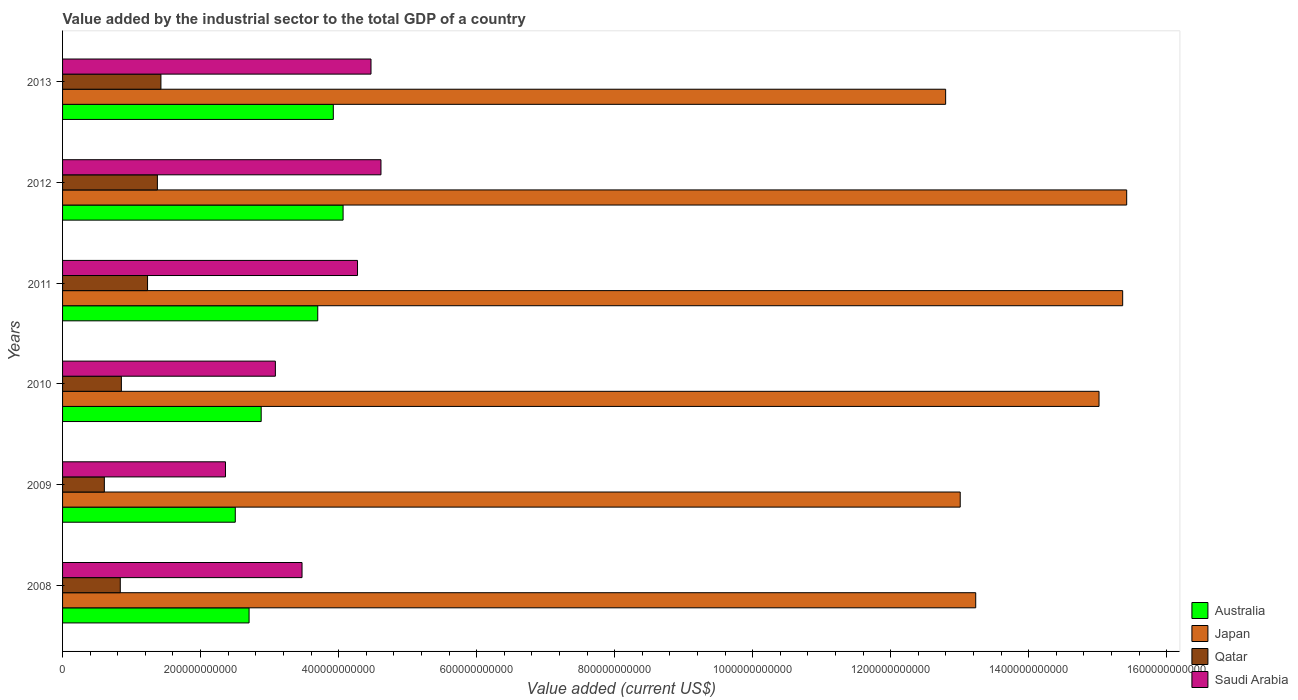How many different coloured bars are there?
Ensure brevity in your answer.  4. Are the number of bars on each tick of the Y-axis equal?
Your answer should be very brief. Yes. How many bars are there on the 1st tick from the top?
Your answer should be very brief. 4. What is the value added by the industrial sector to the total GDP in Qatar in 2013?
Keep it short and to the point. 1.43e+11. Across all years, what is the maximum value added by the industrial sector to the total GDP in Australia?
Offer a terse response. 4.07e+11. Across all years, what is the minimum value added by the industrial sector to the total GDP in Qatar?
Your answer should be very brief. 6.05e+1. In which year was the value added by the industrial sector to the total GDP in Japan maximum?
Provide a short and direct response. 2012. In which year was the value added by the industrial sector to the total GDP in Saudi Arabia minimum?
Keep it short and to the point. 2009. What is the total value added by the industrial sector to the total GDP in Japan in the graph?
Your response must be concise. 8.48e+12. What is the difference between the value added by the industrial sector to the total GDP in Qatar in 2011 and that in 2013?
Keep it short and to the point. -1.94e+1. What is the difference between the value added by the industrial sector to the total GDP in Australia in 2011 and the value added by the industrial sector to the total GDP in Japan in 2012?
Your answer should be very brief. -1.17e+12. What is the average value added by the industrial sector to the total GDP in Australia per year?
Make the answer very short. 3.30e+11. In the year 2013, what is the difference between the value added by the industrial sector to the total GDP in Saudi Arabia and value added by the industrial sector to the total GDP in Japan?
Keep it short and to the point. -8.33e+11. What is the ratio of the value added by the industrial sector to the total GDP in Japan in 2008 to that in 2010?
Your answer should be very brief. 0.88. What is the difference between the highest and the second highest value added by the industrial sector to the total GDP in Qatar?
Offer a very short reply. 5.11e+09. What is the difference between the highest and the lowest value added by the industrial sector to the total GDP in Qatar?
Your answer should be compact. 8.20e+1. Is it the case that in every year, the sum of the value added by the industrial sector to the total GDP in Qatar and value added by the industrial sector to the total GDP in Saudi Arabia is greater than the sum of value added by the industrial sector to the total GDP in Japan and value added by the industrial sector to the total GDP in Australia?
Your answer should be very brief. No. How many years are there in the graph?
Your answer should be compact. 6. What is the difference between two consecutive major ticks on the X-axis?
Provide a short and direct response. 2.00e+11. Does the graph contain grids?
Offer a very short reply. No. How are the legend labels stacked?
Keep it short and to the point. Vertical. What is the title of the graph?
Your answer should be very brief. Value added by the industrial sector to the total GDP of a country. What is the label or title of the X-axis?
Make the answer very short. Value added (current US$). What is the Value added (current US$) in Australia in 2008?
Make the answer very short. 2.70e+11. What is the Value added (current US$) in Japan in 2008?
Provide a succinct answer. 1.32e+12. What is the Value added (current US$) of Qatar in 2008?
Give a very brief answer. 8.36e+1. What is the Value added (current US$) of Saudi Arabia in 2008?
Keep it short and to the point. 3.47e+11. What is the Value added (current US$) in Australia in 2009?
Provide a succinct answer. 2.50e+11. What is the Value added (current US$) in Japan in 2009?
Your answer should be compact. 1.30e+12. What is the Value added (current US$) in Qatar in 2009?
Ensure brevity in your answer.  6.05e+1. What is the Value added (current US$) in Saudi Arabia in 2009?
Your answer should be very brief. 2.36e+11. What is the Value added (current US$) of Australia in 2010?
Your answer should be compact. 2.88e+11. What is the Value added (current US$) in Japan in 2010?
Your response must be concise. 1.50e+12. What is the Value added (current US$) in Qatar in 2010?
Your response must be concise. 8.52e+1. What is the Value added (current US$) of Saudi Arabia in 2010?
Make the answer very short. 3.08e+11. What is the Value added (current US$) of Australia in 2011?
Your answer should be compact. 3.70e+11. What is the Value added (current US$) in Japan in 2011?
Give a very brief answer. 1.54e+12. What is the Value added (current US$) of Qatar in 2011?
Your answer should be very brief. 1.23e+11. What is the Value added (current US$) in Saudi Arabia in 2011?
Ensure brevity in your answer.  4.27e+11. What is the Value added (current US$) in Australia in 2012?
Provide a short and direct response. 4.07e+11. What is the Value added (current US$) of Japan in 2012?
Your answer should be compact. 1.54e+12. What is the Value added (current US$) in Qatar in 2012?
Offer a very short reply. 1.37e+11. What is the Value added (current US$) of Saudi Arabia in 2012?
Offer a terse response. 4.61e+11. What is the Value added (current US$) in Australia in 2013?
Keep it short and to the point. 3.92e+11. What is the Value added (current US$) of Japan in 2013?
Give a very brief answer. 1.28e+12. What is the Value added (current US$) in Qatar in 2013?
Keep it short and to the point. 1.43e+11. What is the Value added (current US$) of Saudi Arabia in 2013?
Make the answer very short. 4.47e+11. Across all years, what is the maximum Value added (current US$) in Australia?
Your answer should be compact. 4.07e+11. Across all years, what is the maximum Value added (current US$) in Japan?
Provide a succinct answer. 1.54e+12. Across all years, what is the maximum Value added (current US$) in Qatar?
Your answer should be very brief. 1.43e+11. Across all years, what is the maximum Value added (current US$) in Saudi Arabia?
Offer a very short reply. 4.61e+11. Across all years, what is the minimum Value added (current US$) in Australia?
Provide a short and direct response. 2.50e+11. Across all years, what is the minimum Value added (current US$) of Japan?
Make the answer very short. 1.28e+12. Across all years, what is the minimum Value added (current US$) of Qatar?
Keep it short and to the point. 6.05e+1. Across all years, what is the minimum Value added (current US$) of Saudi Arabia?
Your answer should be compact. 2.36e+11. What is the total Value added (current US$) in Australia in the graph?
Give a very brief answer. 1.98e+12. What is the total Value added (current US$) in Japan in the graph?
Offer a very short reply. 8.48e+12. What is the total Value added (current US$) in Qatar in the graph?
Ensure brevity in your answer.  6.32e+11. What is the total Value added (current US$) of Saudi Arabia in the graph?
Offer a very short reply. 2.23e+12. What is the difference between the Value added (current US$) of Australia in 2008 and that in 2009?
Keep it short and to the point. 2.00e+1. What is the difference between the Value added (current US$) of Japan in 2008 and that in 2009?
Ensure brevity in your answer.  2.25e+1. What is the difference between the Value added (current US$) of Qatar in 2008 and that in 2009?
Make the answer very short. 2.31e+1. What is the difference between the Value added (current US$) of Saudi Arabia in 2008 and that in 2009?
Ensure brevity in your answer.  1.11e+11. What is the difference between the Value added (current US$) of Australia in 2008 and that in 2010?
Offer a very short reply. -1.75e+1. What is the difference between the Value added (current US$) of Japan in 2008 and that in 2010?
Your answer should be compact. -1.79e+11. What is the difference between the Value added (current US$) of Qatar in 2008 and that in 2010?
Ensure brevity in your answer.  -1.58e+09. What is the difference between the Value added (current US$) of Saudi Arabia in 2008 and that in 2010?
Offer a very short reply. 3.86e+1. What is the difference between the Value added (current US$) in Australia in 2008 and that in 2011?
Your response must be concise. -9.95e+1. What is the difference between the Value added (current US$) of Japan in 2008 and that in 2011?
Your answer should be compact. -2.13e+11. What is the difference between the Value added (current US$) in Qatar in 2008 and that in 2011?
Provide a short and direct response. -3.95e+1. What is the difference between the Value added (current US$) of Saudi Arabia in 2008 and that in 2011?
Offer a terse response. -8.04e+1. What is the difference between the Value added (current US$) in Australia in 2008 and that in 2012?
Give a very brief answer. -1.36e+11. What is the difference between the Value added (current US$) in Japan in 2008 and that in 2012?
Your response must be concise. -2.19e+11. What is the difference between the Value added (current US$) in Qatar in 2008 and that in 2012?
Offer a terse response. -5.38e+1. What is the difference between the Value added (current US$) of Saudi Arabia in 2008 and that in 2012?
Provide a succinct answer. -1.14e+11. What is the difference between the Value added (current US$) in Australia in 2008 and that in 2013?
Keep it short and to the point. -1.22e+11. What is the difference between the Value added (current US$) of Japan in 2008 and that in 2013?
Provide a short and direct response. 4.36e+1. What is the difference between the Value added (current US$) of Qatar in 2008 and that in 2013?
Give a very brief answer. -5.89e+1. What is the difference between the Value added (current US$) in Saudi Arabia in 2008 and that in 2013?
Ensure brevity in your answer.  -1.00e+11. What is the difference between the Value added (current US$) in Australia in 2009 and that in 2010?
Keep it short and to the point. -3.75e+1. What is the difference between the Value added (current US$) of Japan in 2009 and that in 2010?
Your answer should be very brief. -2.01e+11. What is the difference between the Value added (current US$) in Qatar in 2009 and that in 2010?
Keep it short and to the point. -2.47e+1. What is the difference between the Value added (current US$) of Saudi Arabia in 2009 and that in 2010?
Give a very brief answer. -7.23e+1. What is the difference between the Value added (current US$) in Australia in 2009 and that in 2011?
Provide a succinct answer. -1.20e+11. What is the difference between the Value added (current US$) in Japan in 2009 and that in 2011?
Ensure brevity in your answer.  -2.35e+11. What is the difference between the Value added (current US$) in Qatar in 2009 and that in 2011?
Your answer should be compact. -6.26e+1. What is the difference between the Value added (current US$) of Saudi Arabia in 2009 and that in 2011?
Offer a terse response. -1.91e+11. What is the difference between the Value added (current US$) of Australia in 2009 and that in 2012?
Your answer should be compact. -1.56e+11. What is the difference between the Value added (current US$) in Japan in 2009 and that in 2012?
Ensure brevity in your answer.  -2.41e+11. What is the difference between the Value added (current US$) in Qatar in 2009 and that in 2012?
Ensure brevity in your answer.  -7.69e+1. What is the difference between the Value added (current US$) in Saudi Arabia in 2009 and that in 2012?
Make the answer very short. -2.25e+11. What is the difference between the Value added (current US$) in Australia in 2009 and that in 2013?
Your answer should be very brief. -1.42e+11. What is the difference between the Value added (current US$) in Japan in 2009 and that in 2013?
Your response must be concise. 2.11e+1. What is the difference between the Value added (current US$) in Qatar in 2009 and that in 2013?
Give a very brief answer. -8.20e+1. What is the difference between the Value added (current US$) of Saudi Arabia in 2009 and that in 2013?
Your answer should be very brief. -2.11e+11. What is the difference between the Value added (current US$) of Australia in 2010 and that in 2011?
Keep it short and to the point. -8.20e+1. What is the difference between the Value added (current US$) in Japan in 2010 and that in 2011?
Keep it short and to the point. -3.43e+1. What is the difference between the Value added (current US$) in Qatar in 2010 and that in 2011?
Your answer should be very brief. -3.79e+1. What is the difference between the Value added (current US$) of Saudi Arabia in 2010 and that in 2011?
Provide a succinct answer. -1.19e+11. What is the difference between the Value added (current US$) in Australia in 2010 and that in 2012?
Your answer should be very brief. -1.19e+11. What is the difference between the Value added (current US$) in Japan in 2010 and that in 2012?
Your answer should be very brief. -4.01e+1. What is the difference between the Value added (current US$) in Qatar in 2010 and that in 2012?
Give a very brief answer. -5.22e+1. What is the difference between the Value added (current US$) in Saudi Arabia in 2010 and that in 2012?
Offer a terse response. -1.53e+11. What is the difference between the Value added (current US$) of Australia in 2010 and that in 2013?
Your answer should be compact. -1.05e+11. What is the difference between the Value added (current US$) of Japan in 2010 and that in 2013?
Offer a very short reply. 2.22e+11. What is the difference between the Value added (current US$) in Qatar in 2010 and that in 2013?
Give a very brief answer. -5.73e+1. What is the difference between the Value added (current US$) in Saudi Arabia in 2010 and that in 2013?
Keep it short and to the point. -1.39e+11. What is the difference between the Value added (current US$) of Australia in 2011 and that in 2012?
Keep it short and to the point. -3.67e+1. What is the difference between the Value added (current US$) of Japan in 2011 and that in 2012?
Give a very brief answer. -5.83e+09. What is the difference between the Value added (current US$) of Qatar in 2011 and that in 2012?
Provide a succinct answer. -1.43e+1. What is the difference between the Value added (current US$) in Saudi Arabia in 2011 and that in 2012?
Ensure brevity in your answer.  -3.40e+1. What is the difference between the Value added (current US$) of Australia in 2011 and that in 2013?
Offer a very short reply. -2.25e+1. What is the difference between the Value added (current US$) of Japan in 2011 and that in 2013?
Your answer should be compact. 2.57e+11. What is the difference between the Value added (current US$) of Qatar in 2011 and that in 2013?
Provide a short and direct response. -1.94e+1. What is the difference between the Value added (current US$) in Saudi Arabia in 2011 and that in 2013?
Ensure brevity in your answer.  -1.95e+1. What is the difference between the Value added (current US$) of Australia in 2012 and that in 2013?
Offer a terse response. 1.42e+1. What is the difference between the Value added (current US$) of Japan in 2012 and that in 2013?
Provide a succinct answer. 2.62e+11. What is the difference between the Value added (current US$) in Qatar in 2012 and that in 2013?
Offer a very short reply. -5.11e+09. What is the difference between the Value added (current US$) in Saudi Arabia in 2012 and that in 2013?
Offer a very short reply. 1.44e+1. What is the difference between the Value added (current US$) in Australia in 2008 and the Value added (current US$) in Japan in 2009?
Ensure brevity in your answer.  -1.03e+12. What is the difference between the Value added (current US$) in Australia in 2008 and the Value added (current US$) in Qatar in 2009?
Offer a very short reply. 2.10e+11. What is the difference between the Value added (current US$) in Australia in 2008 and the Value added (current US$) in Saudi Arabia in 2009?
Provide a short and direct response. 3.42e+1. What is the difference between the Value added (current US$) of Japan in 2008 and the Value added (current US$) of Qatar in 2009?
Your response must be concise. 1.26e+12. What is the difference between the Value added (current US$) in Japan in 2008 and the Value added (current US$) in Saudi Arabia in 2009?
Your response must be concise. 1.09e+12. What is the difference between the Value added (current US$) in Qatar in 2008 and the Value added (current US$) in Saudi Arabia in 2009?
Offer a very short reply. -1.52e+11. What is the difference between the Value added (current US$) of Australia in 2008 and the Value added (current US$) of Japan in 2010?
Your answer should be very brief. -1.23e+12. What is the difference between the Value added (current US$) in Australia in 2008 and the Value added (current US$) in Qatar in 2010?
Offer a terse response. 1.85e+11. What is the difference between the Value added (current US$) of Australia in 2008 and the Value added (current US$) of Saudi Arabia in 2010?
Make the answer very short. -3.81e+1. What is the difference between the Value added (current US$) of Japan in 2008 and the Value added (current US$) of Qatar in 2010?
Provide a succinct answer. 1.24e+12. What is the difference between the Value added (current US$) of Japan in 2008 and the Value added (current US$) of Saudi Arabia in 2010?
Make the answer very short. 1.01e+12. What is the difference between the Value added (current US$) of Qatar in 2008 and the Value added (current US$) of Saudi Arabia in 2010?
Provide a succinct answer. -2.25e+11. What is the difference between the Value added (current US$) of Australia in 2008 and the Value added (current US$) of Japan in 2011?
Ensure brevity in your answer.  -1.27e+12. What is the difference between the Value added (current US$) of Australia in 2008 and the Value added (current US$) of Qatar in 2011?
Give a very brief answer. 1.47e+11. What is the difference between the Value added (current US$) of Australia in 2008 and the Value added (current US$) of Saudi Arabia in 2011?
Your answer should be compact. -1.57e+11. What is the difference between the Value added (current US$) of Japan in 2008 and the Value added (current US$) of Qatar in 2011?
Make the answer very short. 1.20e+12. What is the difference between the Value added (current US$) in Japan in 2008 and the Value added (current US$) in Saudi Arabia in 2011?
Provide a short and direct response. 8.96e+11. What is the difference between the Value added (current US$) in Qatar in 2008 and the Value added (current US$) in Saudi Arabia in 2011?
Offer a very short reply. -3.44e+11. What is the difference between the Value added (current US$) in Australia in 2008 and the Value added (current US$) in Japan in 2012?
Ensure brevity in your answer.  -1.27e+12. What is the difference between the Value added (current US$) of Australia in 2008 and the Value added (current US$) of Qatar in 2012?
Your answer should be very brief. 1.33e+11. What is the difference between the Value added (current US$) in Australia in 2008 and the Value added (current US$) in Saudi Arabia in 2012?
Make the answer very short. -1.91e+11. What is the difference between the Value added (current US$) in Japan in 2008 and the Value added (current US$) in Qatar in 2012?
Give a very brief answer. 1.19e+12. What is the difference between the Value added (current US$) of Japan in 2008 and the Value added (current US$) of Saudi Arabia in 2012?
Provide a short and direct response. 8.62e+11. What is the difference between the Value added (current US$) in Qatar in 2008 and the Value added (current US$) in Saudi Arabia in 2012?
Keep it short and to the point. -3.78e+11. What is the difference between the Value added (current US$) in Australia in 2008 and the Value added (current US$) in Japan in 2013?
Your answer should be very brief. -1.01e+12. What is the difference between the Value added (current US$) of Australia in 2008 and the Value added (current US$) of Qatar in 2013?
Provide a succinct answer. 1.28e+11. What is the difference between the Value added (current US$) of Australia in 2008 and the Value added (current US$) of Saudi Arabia in 2013?
Provide a short and direct response. -1.77e+11. What is the difference between the Value added (current US$) in Japan in 2008 and the Value added (current US$) in Qatar in 2013?
Offer a terse response. 1.18e+12. What is the difference between the Value added (current US$) of Japan in 2008 and the Value added (current US$) of Saudi Arabia in 2013?
Keep it short and to the point. 8.76e+11. What is the difference between the Value added (current US$) of Qatar in 2008 and the Value added (current US$) of Saudi Arabia in 2013?
Offer a terse response. -3.63e+11. What is the difference between the Value added (current US$) of Australia in 2009 and the Value added (current US$) of Japan in 2010?
Your response must be concise. -1.25e+12. What is the difference between the Value added (current US$) of Australia in 2009 and the Value added (current US$) of Qatar in 2010?
Your answer should be compact. 1.65e+11. What is the difference between the Value added (current US$) in Australia in 2009 and the Value added (current US$) in Saudi Arabia in 2010?
Ensure brevity in your answer.  -5.81e+1. What is the difference between the Value added (current US$) of Japan in 2009 and the Value added (current US$) of Qatar in 2010?
Your answer should be very brief. 1.22e+12. What is the difference between the Value added (current US$) of Japan in 2009 and the Value added (current US$) of Saudi Arabia in 2010?
Keep it short and to the point. 9.92e+11. What is the difference between the Value added (current US$) in Qatar in 2009 and the Value added (current US$) in Saudi Arabia in 2010?
Ensure brevity in your answer.  -2.48e+11. What is the difference between the Value added (current US$) in Australia in 2009 and the Value added (current US$) in Japan in 2011?
Give a very brief answer. -1.29e+12. What is the difference between the Value added (current US$) in Australia in 2009 and the Value added (current US$) in Qatar in 2011?
Make the answer very short. 1.27e+11. What is the difference between the Value added (current US$) of Australia in 2009 and the Value added (current US$) of Saudi Arabia in 2011?
Give a very brief answer. -1.77e+11. What is the difference between the Value added (current US$) of Japan in 2009 and the Value added (current US$) of Qatar in 2011?
Your answer should be very brief. 1.18e+12. What is the difference between the Value added (current US$) in Japan in 2009 and the Value added (current US$) in Saudi Arabia in 2011?
Your answer should be compact. 8.73e+11. What is the difference between the Value added (current US$) in Qatar in 2009 and the Value added (current US$) in Saudi Arabia in 2011?
Your answer should be compact. -3.67e+11. What is the difference between the Value added (current US$) of Australia in 2009 and the Value added (current US$) of Japan in 2012?
Provide a succinct answer. -1.29e+12. What is the difference between the Value added (current US$) in Australia in 2009 and the Value added (current US$) in Qatar in 2012?
Your answer should be compact. 1.13e+11. What is the difference between the Value added (current US$) of Australia in 2009 and the Value added (current US$) of Saudi Arabia in 2012?
Your response must be concise. -2.11e+11. What is the difference between the Value added (current US$) in Japan in 2009 and the Value added (current US$) in Qatar in 2012?
Give a very brief answer. 1.16e+12. What is the difference between the Value added (current US$) in Japan in 2009 and the Value added (current US$) in Saudi Arabia in 2012?
Offer a very short reply. 8.39e+11. What is the difference between the Value added (current US$) in Qatar in 2009 and the Value added (current US$) in Saudi Arabia in 2012?
Ensure brevity in your answer.  -4.01e+11. What is the difference between the Value added (current US$) in Australia in 2009 and the Value added (current US$) in Japan in 2013?
Your answer should be compact. -1.03e+12. What is the difference between the Value added (current US$) of Australia in 2009 and the Value added (current US$) of Qatar in 2013?
Provide a short and direct response. 1.08e+11. What is the difference between the Value added (current US$) in Australia in 2009 and the Value added (current US$) in Saudi Arabia in 2013?
Your response must be concise. -1.97e+11. What is the difference between the Value added (current US$) of Japan in 2009 and the Value added (current US$) of Qatar in 2013?
Your answer should be compact. 1.16e+12. What is the difference between the Value added (current US$) of Japan in 2009 and the Value added (current US$) of Saudi Arabia in 2013?
Give a very brief answer. 8.54e+11. What is the difference between the Value added (current US$) in Qatar in 2009 and the Value added (current US$) in Saudi Arabia in 2013?
Your response must be concise. -3.86e+11. What is the difference between the Value added (current US$) of Australia in 2010 and the Value added (current US$) of Japan in 2011?
Keep it short and to the point. -1.25e+12. What is the difference between the Value added (current US$) in Australia in 2010 and the Value added (current US$) in Qatar in 2011?
Keep it short and to the point. 1.65e+11. What is the difference between the Value added (current US$) of Australia in 2010 and the Value added (current US$) of Saudi Arabia in 2011?
Offer a very short reply. -1.40e+11. What is the difference between the Value added (current US$) of Japan in 2010 and the Value added (current US$) of Qatar in 2011?
Offer a terse response. 1.38e+12. What is the difference between the Value added (current US$) in Japan in 2010 and the Value added (current US$) in Saudi Arabia in 2011?
Your answer should be compact. 1.07e+12. What is the difference between the Value added (current US$) of Qatar in 2010 and the Value added (current US$) of Saudi Arabia in 2011?
Your response must be concise. -3.42e+11. What is the difference between the Value added (current US$) in Australia in 2010 and the Value added (current US$) in Japan in 2012?
Ensure brevity in your answer.  -1.25e+12. What is the difference between the Value added (current US$) of Australia in 2010 and the Value added (current US$) of Qatar in 2012?
Offer a very short reply. 1.50e+11. What is the difference between the Value added (current US$) of Australia in 2010 and the Value added (current US$) of Saudi Arabia in 2012?
Offer a terse response. -1.74e+11. What is the difference between the Value added (current US$) of Japan in 2010 and the Value added (current US$) of Qatar in 2012?
Make the answer very short. 1.36e+12. What is the difference between the Value added (current US$) of Japan in 2010 and the Value added (current US$) of Saudi Arabia in 2012?
Your answer should be very brief. 1.04e+12. What is the difference between the Value added (current US$) in Qatar in 2010 and the Value added (current US$) in Saudi Arabia in 2012?
Keep it short and to the point. -3.76e+11. What is the difference between the Value added (current US$) in Australia in 2010 and the Value added (current US$) in Japan in 2013?
Ensure brevity in your answer.  -9.92e+11. What is the difference between the Value added (current US$) of Australia in 2010 and the Value added (current US$) of Qatar in 2013?
Give a very brief answer. 1.45e+11. What is the difference between the Value added (current US$) in Australia in 2010 and the Value added (current US$) in Saudi Arabia in 2013?
Provide a succinct answer. -1.59e+11. What is the difference between the Value added (current US$) in Japan in 2010 and the Value added (current US$) in Qatar in 2013?
Give a very brief answer. 1.36e+12. What is the difference between the Value added (current US$) of Japan in 2010 and the Value added (current US$) of Saudi Arabia in 2013?
Your answer should be very brief. 1.05e+12. What is the difference between the Value added (current US$) in Qatar in 2010 and the Value added (current US$) in Saudi Arabia in 2013?
Offer a very short reply. -3.62e+11. What is the difference between the Value added (current US$) of Australia in 2011 and the Value added (current US$) of Japan in 2012?
Give a very brief answer. -1.17e+12. What is the difference between the Value added (current US$) in Australia in 2011 and the Value added (current US$) in Qatar in 2012?
Your response must be concise. 2.32e+11. What is the difference between the Value added (current US$) in Australia in 2011 and the Value added (current US$) in Saudi Arabia in 2012?
Your answer should be compact. -9.16e+1. What is the difference between the Value added (current US$) in Japan in 2011 and the Value added (current US$) in Qatar in 2012?
Your answer should be very brief. 1.40e+12. What is the difference between the Value added (current US$) of Japan in 2011 and the Value added (current US$) of Saudi Arabia in 2012?
Your answer should be compact. 1.07e+12. What is the difference between the Value added (current US$) of Qatar in 2011 and the Value added (current US$) of Saudi Arabia in 2012?
Your answer should be very brief. -3.38e+11. What is the difference between the Value added (current US$) of Australia in 2011 and the Value added (current US$) of Japan in 2013?
Provide a succinct answer. -9.10e+11. What is the difference between the Value added (current US$) of Australia in 2011 and the Value added (current US$) of Qatar in 2013?
Offer a very short reply. 2.27e+11. What is the difference between the Value added (current US$) of Australia in 2011 and the Value added (current US$) of Saudi Arabia in 2013?
Provide a short and direct response. -7.72e+1. What is the difference between the Value added (current US$) in Japan in 2011 and the Value added (current US$) in Qatar in 2013?
Your answer should be very brief. 1.39e+12. What is the difference between the Value added (current US$) of Japan in 2011 and the Value added (current US$) of Saudi Arabia in 2013?
Your response must be concise. 1.09e+12. What is the difference between the Value added (current US$) in Qatar in 2011 and the Value added (current US$) in Saudi Arabia in 2013?
Keep it short and to the point. -3.24e+11. What is the difference between the Value added (current US$) of Australia in 2012 and the Value added (current US$) of Japan in 2013?
Ensure brevity in your answer.  -8.73e+11. What is the difference between the Value added (current US$) in Australia in 2012 and the Value added (current US$) in Qatar in 2013?
Your response must be concise. 2.64e+11. What is the difference between the Value added (current US$) of Australia in 2012 and the Value added (current US$) of Saudi Arabia in 2013?
Provide a short and direct response. -4.04e+1. What is the difference between the Value added (current US$) of Japan in 2012 and the Value added (current US$) of Qatar in 2013?
Your answer should be very brief. 1.40e+12. What is the difference between the Value added (current US$) in Japan in 2012 and the Value added (current US$) in Saudi Arabia in 2013?
Provide a succinct answer. 1.10e+12. What is the difference between the Value added (current US$) in Qatar in 2012 and the Value added (current US$) in Saudi Arabia in 2013?
Keep it short and to the point. -3.10e+11. What is the average Value added (current US$) in Australia per year?
Your answer should be compact. 3.30e+11. What is the average Value added (current US$) in Japan per year?
Your response must be concise. 1.41e+12. What is the average Value added (current US$) in Qatar per year?
Your response must be concise. 1.05e+11. What is the average Value added (current US$) of Saudi Arabia per year?
Offer a terse response. 3.71e+11. In the year 2008, what is the difference between the Value added (current US$) of Australia and Value added (current US$) of Japan?
Your answer should be very brief. -1.05e+12. In the year 2008, what is the difference between the Value added (current US$) of Australia and Value added (current US$) of Qatar?
Your response must be concise. 1.87e+11. In the year 2008, what is the difference between the Value added (current US$) in Australia and Value added (current US$) in Saudi Arabia?
Your answer should be very brief. -7.67e+1. In the year 2008, what is the difference between the Value added (current US$) of Japan and Value added (current US$) of Qatar?
Ensure brevity in your answer.  1.24e+12. In the year 2008, what is the difference between the Value added (current US$) of Japan and Value added (current US$) of Saudi Arabia?
Give a very brief answer. 9.76e+11. In the year 2008, what is the difference between the Value added (current US$) of Qatar and Value added (current US$) of Saudi Arabia?
Give a very brief answer. -2.63e+11. In the year 2009, what is the difference between the Value added (current US$) of Australia and Value added (current US$) of Japan?
Offer a terse response. -1.05e+12. In the year 2009, what is the difference between the Value added (current US$) in Australia and Value added (current US$) in Qatar?
Make the answer very short. 1.90e+11. In the year 2009, what is the difference between the Value added (current US$) in Australia and Value added (current US$) in Saudi Arabia?
Give a very brief answer. 1.42e+1. In the year 2009, what is the difference between the Value added (current US$) of Japan and Value added (current US$) of Qatar?
Make the answer very short. 1.24e+12. In the year 2009, what is the difference between the Value added (current US$) in Japan and Value added (current US$) in Saudi Arabia?
Keep it short and to the point. 1.06e+12. In the year 2009, what is the difference between the Value added (current US$) of Qatar and Value added (current US$) of Saudi Arabia?
Make the answer very short. -1.76e+11. In the year 2010, what is the difference between the Value added (current US$) in Australia and Value added (current US$) in Japan?
Ensure brevity in your answer.  -1.21e+12. In the year 2010, what is the difference between the Value added (current US$) of Australia and Value added (current US$) of Qatar?
Your answer should be very brief. 2.03e+11. In the year 2010, what is the difference between the Value added (current US$) in Australia and Value added (current US$) in Saudi Arabia?
Provide a succinct answer. -2.06e+1. In the year 2010, what is the difference between the Value added (current US$) of Japan and Value added (current US$) of Qatar?
Provide a short and direct response. 1.42e+12. In the year 2010, what is the difference between the Value added (current US$) of Japan and Value added (current US$) of Saudi Arabia?
Provide a short and direct response. 1.19e+12. In the year 2010, what is the difference between the Value added (current US$) of Qatar and Value added (current US$) of Saudi Arabia?
Offer a very short reply. -2.23e+11. In the year 2011, what is the difference between the Value added (current US$) in Australia and Value added (current US$) in Japan?
Provide a short and direct response. -1.17e+12. In the year 2011, what is the difference between the Value added (current US$) of Australia and Value added (current US$) of Qatar?
Provide a succinct answer. 2.47e+11. In the year 2011, what is the difference between the Value added (current US$) in Australia and Value added (current US$) in Saudi Arabia?
Give a very brief answer. -5.76e+1. In the year 2011, what is the difference between the Value added (current US$) in Japan and Value added (current US$) in Qatar?
Provide a short and direct response. 1.41e+12. In the year 2011, what is the difference between the Value added (current US$) of Japan and Value added (current US$) of Saudi Arabia?
Keep it short and to the point. 1.11e+12. In the year 2011, what is the difference between the Value added (current US$) of Qatar and Value added (current US$) of Saudi Arabia?
Your answer should be very brief. -3.04e+11. In the year 2012, what is the difference between the Value added (current US$) of Australia and Value added (current US$) of Japan?
Keep it short and to the point. -1.14e+12. In the year 2012, what is the difference between the Value added (current US$) in Australia and Value added (current US$) in Qatar?
Offer a very short reply. 2.69e+11. In the year 2012, what is the difference between the Value added (current US$) in Australia and Value added (current US$) in Saudi Arabia?
Your response must be concise. -5.49e+1. In the year 2012, what is the difference between the Value added (current US$) in Japan and Value added (current US$) in Qatar?
Provide a succinct answer. 1.40e+12. In the year 2012, what is the difference between the Value added (current US$) of Japan and Value added (current US$) of Saudi Arabia?
Your answer should be very brief. 1.08e+12. In the year 2012, what is the difference between the Value added (current US$) of Qatar and Value added (current US$) of Saudi Arabia?
Ensure brevity in your answer.  -3.24e+11. In the year 2013, what is the difference between the Value added (current US$) of Australia and Value added (current US$) of Japan?
Your response must be concise. -8.87e+11. In the year 2013, what is the difference between the Value added (current US$) in Australia and Value added (current US$) in Qatar?
Give a very brief answer. 2.50e+11. In the year 2013, what is the difference between the Value added (current US$) in Australia and Value added (current US$) in Saudi Arabia?
Provide a short and direct response. -5.46e+1. In the year 2013, what is the difference between the Value added (current US$) in Japan and Value added (current US$) in Qatar?
Make the answer very short. 1.14e+12. In the year 2013, what is the difference between the Value added (current US$) in Japan and Value added (current US$) in Saudi Arabia?
Offer a terse response. 8.33e+11. In the year 2013, what is the difference between the Value added (current US$) of Qatar and Value added (current US$) of Saudi Arabia?
Make the answer very short. -3.04e+11. What is the ratio of the Value added (current US$) of Australia in 2008 to that in 2009?
Offer a terse response. 1.08. What is the ratio of the Value added (current US$) in Japan in 2008 to that in 2009?
Your answer should be compact. 1.02. What is the ratio of the Value added (current US$) of Qatar in 2008 to that in 2009?
Ensure brevity in your answer.  1.38. What is the ratio of the Value added (current US$) in Saudi Arabia in 2008 to that in 2009?
Your answer should be very brief. 1.47. What is the ratio of the Value added (current US$) in Australia in 2008 to that in 2010?
Your response must be concise. 0.94. What is the ratio of the Value added (current US$) in Japan in 2008 to that in 2010?
Provide a succinct answer. 0.88. What is the ratio of the Value added (current US$) of Qatar in 2008 to that in 2010?
Provide a succinct answer. 0.98. What is the ratio of the Value added (current US$) of Saudi Arabia in 2008 to that in 2010?
Your response must be concise. 1.13. What is the ratio of the Value added (current US$) in Australia in 2008 to that in 2011?
Give a very brief answer. 0.73. What is the ratio of the Value added (current US$) of Japan in 2008 to that in 2011?
Ensure brevity in your answer.  0.86. What is the ratio of the Value added (current US$) of Qatar in 2008 to that in 2011?
Your answer should be compact. 0.68. What is the ratio of the Value added (current US$) in Saudi Arabia in 2008 to that in 2011?
Your response must be concise. 0.81. What is the ratio of the Value added (current US$) of Australia in 2008 to that in 2012?
Keep it short and to the point. 0.66. What is the ratio of the Value added (current US$) of Japan in 2008 to that in 2012?
Your response must be concise. 0.86. What is the ratio of the Value added (current US$) in Qatar in 2008 to that in 2012?
Make the answer very short. 0.61. What is the ratio of the Value added (current US$) in Saudi Arabia in 2008 to that in 2012?
Give a very brief answer. 0.75. What is the ratio of the Value added (current US$) of Australia in 2008 to that in 2013?
Ensure brevity in your answer.  0.69. What is the ratio of the Value added (current US$) of Japan in 2008 to that in 2013?
Ensure brevity in your answer.  1.03. What is the ratio of the Value added (current US$) of Qatar in 2008 to that in 2013?
Offer a terse response. 0.59. What is the ratio of the Value added (current US$) of Saudi Arabia in 2008 to that in 2013?
Make the answer very short. 0.78. What is the ratio of the Value added (current US$) in Australia in 2009 to that in 2010?
Provide a succinct answer. 0.87. What is the ratio of the Value added (current US$) in Japan in 2009 to that in 2010?
Give a very brief answer. 0.87. What is the ratio of the Value added (current US$) of Qatar in 2009 to that in 2010?
Offer a very short reply. 0.71. What is the ratio of the Value added (current US$) of Saudi Arabia in 2009 to that in 2010?
Ensure brevity in your answer.  0.77. What is the ratio of the Value added (current US$) in Australia in 2009 to that in 2011?
Give a very brief answer. 0.68. What is the ratio of the Value added (current US$) of Japan in 2009 to that in 2011?
Ensure brevity in your answer.  0.85. What is the ratio of the Value added (current US$) in Qatar in 2009 to that in 2011?
Your answer should be very brief. 0.49. What is the ratio of the Value added (current US$) of Saudi Arabia in 2009 to that in 2011?
Offer a terse response. 0.55. What is the ratio of the Value added (current US$) of Australia in 2009 to that in 2012?
Provide a short and direct response. 0.62. What is the ratio of the Value added (current US$) of Japan in 2009 to that in 2012?
Your response must be concise. 0.84. What is the ratio of the Value added (current US$) in Qatar in 2009 to that in 2012?
Offer a very short reply. 0.44. What is the ratio of the Value added (current US$) in Saudi Arabia in 2009 to that in 2012?
Provide a short and direct response. 0.51. What is the ratio of the Value added (current US$) in Australia in 2009 to that in 2013?
Your answer should be very brief. 0.64. What is the ratio of the Value added (current US$) of Japan in 2009 to that in 2013?
Offer a terse response. 1.02. What is the ratio of the Value added (current US$) of Qatar in 2009 to that in 2013?
Offer a terse response. 0.42. What is the ratio of the Value added (current US$) of Saudi Arabia in 2009 to that in 2013?
Your answer should be compact. 0.53. What is the ratio of the Value added (current US$) of Australia in 2010 to that in 2011?
Your answer should be very brief. 0.78. What is the ratio of the Value added (current US$) in Japan in 2010 to that in 2011?
Your answer should be very brief. 0.98. What is the ratio of the Value added (current US$) of Qatar in 2010 to that in 2011?
Provide a succinct answer. 0.69. What is the ratio of the Value added (current US$) of Saudi Arabia in 2010 to that in 2011?
Offer a terse response. 0.72. What is the ratio of the Value added (current US$) of Australia in 2010 to that in 2012?
Your response must be concise. 0.71. What is the ratio of the Value added (current US$) in Qatar in 2010 to that in 2012?
Your response must be concise. 0.62. What is the ratio of the Value added (current US$) of Saudi Arabia in 2010 to that in 2012?
Give a very brief answer. 0.67. What is the ratio of the Value added (current US$) in Australia in 2010 to that in 2013?
Your answer should be very brief. 0.73. What is the ratio of the Value added (current US$) in Japan in 2010 to that in 2013?
Offer a terse response. 1.17. What is the ratio of the Value added (current US$) of Qatar in 2010 to that in 2013?
Offer a very short reply. 0.6. What is the ratio of the Value added (current US$) of Saudi Arabia in 2010 to that in 2013?
Offer a very short reply. 0.69. What is the ratio of the Value added (current US$) in Australia in 2011 to that in 2012?
Your answer should be very brief. 0.91. What is the ratio of the Value added (current US$) of Qatar in 2011 to that in 2012?
Ensure brevity in your answer.  0.9. What is the ratio of the Value added (current US$) of Saudi Arabia in 2011 to that in 2012?
Give a very brief answer. 0.93. What is the ratio of the Value added (current US$) of Australia in 2011 to that in 2013?
Make the answer very short. 0.94. What is the ratio of the Value added (current US$) of Japan in 2011 to that in 2013?
Your response must be concise. 1.2. What is the ratio of the Value added (current US$) of Qatar in 2011 to that in 2013?
Offer a terse response. 0.86. What is the ratio of the Value added (current US$) in Saudi Arabia in 2011 to that in 2013?
Provide a succinct answer. 0.96. What is the ratio of the Value added (current US$) of Australia in 2012 to that in 2013?
Make the answer very short. 1.04. What is the ratio of the Value added (current US$) of Japan in 2012 to that in 2013?
Your answer should be very brief. 1.21. What is the ratio of the Value added (current US$) of Qatar in 2012 to that in 2013?
Make the answer very short. 0.96. What is the ratio of the Value added (current US$) of Saudi Arabia in 2012 to that in 2013?
Offer a very short reply. 1.03. What is the difference between the highest and the second highest Value added (current US$) in Australia?
Your response must be concise. 1.42e+1. What is the difference between the highest and the second highest Value added (current US$) in Japan?
Provide a succinct answer. 5.83e+09. What is the difference between the highest and the second highest Value added (current US$) in Qatar?
Make the answer very short. 5.11e+09. What is the difference between the highest and the second highest Value added (current US$) in Saudi Arabia?
Give a very brief answer. 1.44e+1. What is the difference between the highest and the lowest Value added (current US$) of Australia?
Your answer should be very brief. 1.56e+11. What is the difference between the highest and the lowest Value added (current US$) of Japan?
Ensure brevity in your answer.  2.62e+11. What is the difference between the highest and the lowest Value added (current US$) in Qatar?
Provide a short and direct response. 8.20e+1. What is the difference between the highest and the lowest Value added (current US$) of Saudi Arabia?
Your response must be concise. 2.25e+11. 